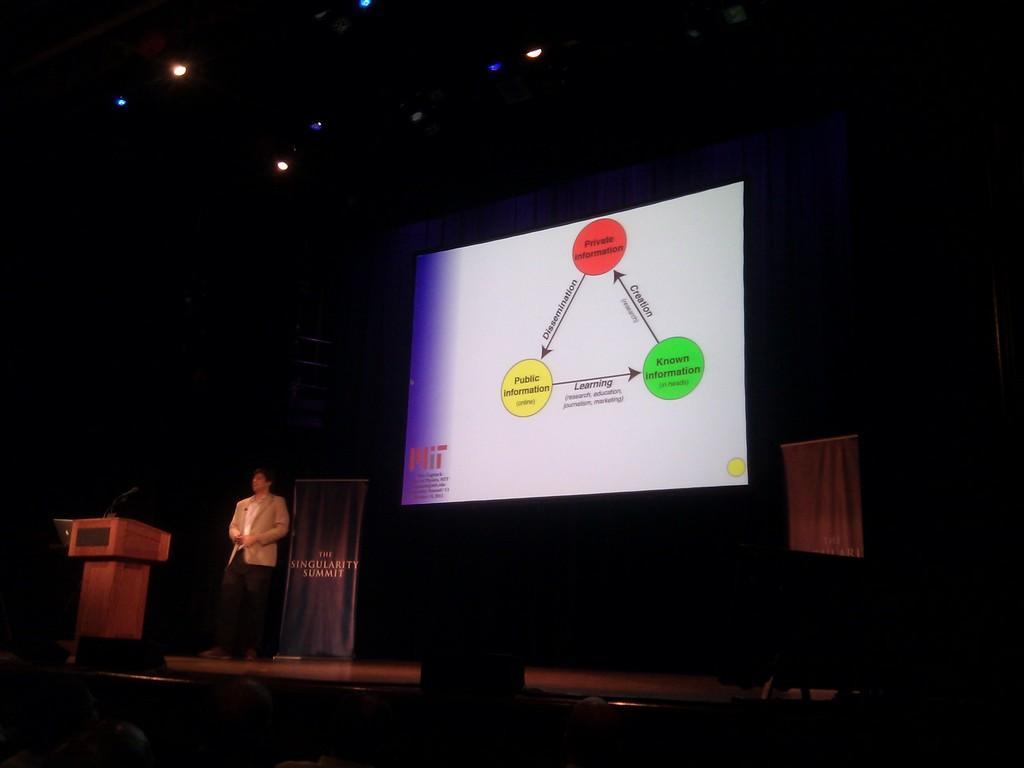Describe this image in one or two sentences. This image is taken indoors. At the bottom of the image there are a few people. In the background there is a screen with a text on it. In the middle of the image a man is standing on the dais near the podium and there is a poster with text on it. At the top of the image there are a few lamps. 